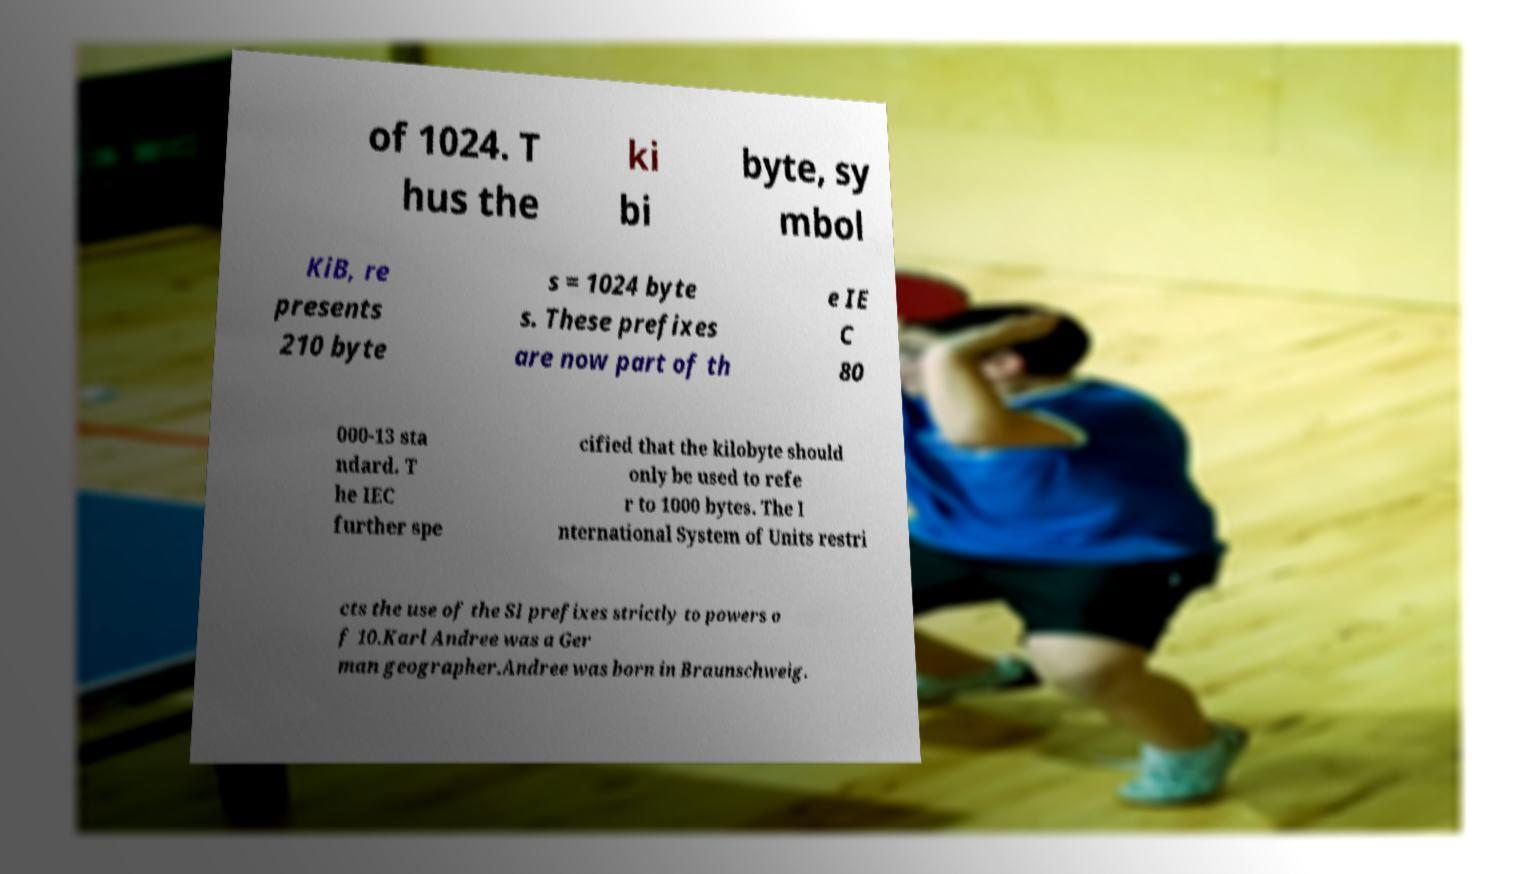For documentation purposes, I need the text within this image transcribed. Could you provide that? of 1024. T hus the ki bi byte, sy mbol KiB, re presents 210 byte s = 1024 byte s. These prefixes are now part of th e IE C 80 000-13 sta ndard. T he IEC further spe cified that the kilobyte should only be used to refe r to 1000 bytes. The I nternational System of Units restri cts the use of the SI prefixes strictly to powers o f 10.Karl Andree was a Ger man geographer.Andree was born in Braunschweig. 